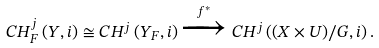<formula> <loc_0><loc_0><loc_500><loc_500>C H ^ { j } _ { F } \left ( Y , i \right ) \cong C H ^ { j } \left ( Y _ { F } , i \right ) \xrightarrow { f ^ { * } } C H ^ { j } \left ( { \left ( X \times U \right ) } / G , i \right ) .</formula> 